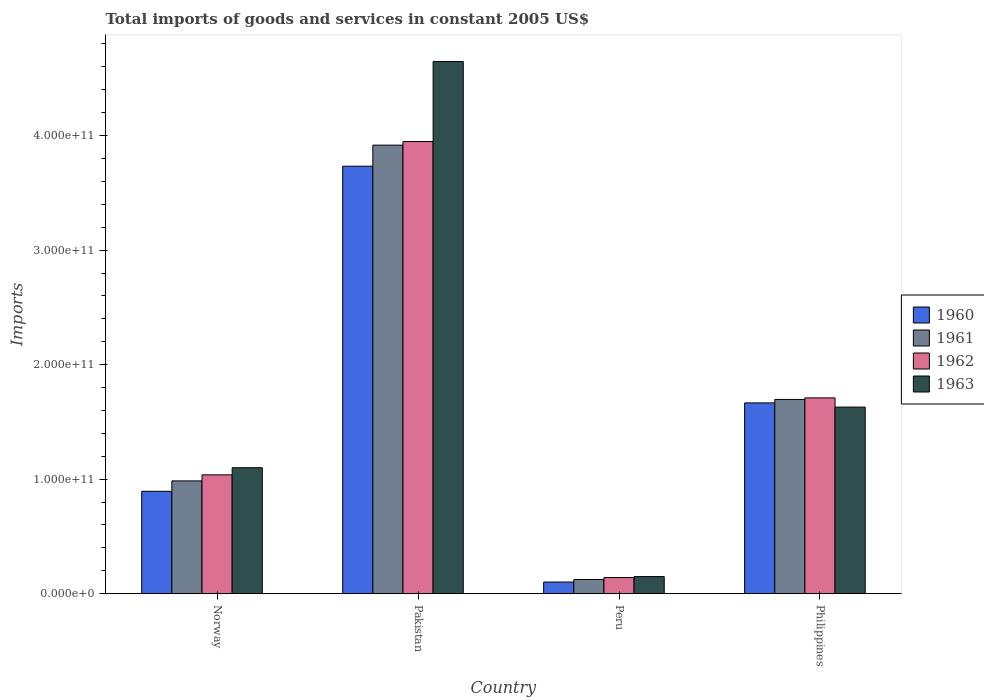How many groups of bars are there?
Offer a terse response. 4. Are the number of bars per tick equal to the number of legend labels?
Ensure brevity in your answer.  Yes. Are the number of bars on each tick of the X-axis equal?
Offer a very short reply. Yes. What is the total imports of goods and services in 1962 in Norway?
Your answer should be very brief. 1.04e+11. Across all countries, what is the maximum total imports of goods and services in 1960?
Offer a very short reply. 3.73e+11. Across all countries, what is the minimum total imports of goods and services in 1963?
Ensure brevity in your answer.  1.49e+1. In which country was the total imports of goods and services in 1963 minimum?
Your answer should be compact. Peru. What is the total total imports of goods and services in 1960 in the graph?
Ensure brevity in your answer.  6.39e+11. What is the difference between the total imports of goods and services in 1960 in Pakistan and that in Peru?
Provide a short and direct response. 3.63e+11. What is the difference between the total imports of goods and services in 1960 in Norway and the total imports of goods and services in 1961 in Peru?
Your response must be concise. 7.70e+1. What is the average total imports of goods and services in 1960 per country?
Provide a short and direct response. 1.60e+11. What is the difference between the total imports of goods and services of/in 1963 and total imports of goods and services of/in 1961 in Peru?
Give a very brief answer. 2.54e+09. In how many countries, is the total imports of goods and services in 1962 greater than 240000000000 US$?
Make the answer very short. 1. What is the ratio of the total imports of goods and services in 1963 in Peru to that in Philippines?
Make the answer very short. 0.09. Is the difference between the total imports of goods and services in 1963 in Norway and Peru greater than the difference between the total imports of goods and services in 1961 in Norway and Peru?
Keep it short and to the point. Yes. What is the difference between the highest and the second highest total imports of goods and services in 1960?
Your answer should be compact. 2.84e+11. What is the difference between the highest and the lowest total imports of goods and services in 1963?
Ensure brevity in your answer.  4.50e+11. In how many countries, is the total imports of goods and services in 1962 greater than the average total imports of goods and services in 1962 taken over all countries?
Provide a short and direct response. 2. Is the sum of the total imports of goods and services in 1960 in Peru and Philippines greater than the maximum total imports of goods and services in 1963 across all countries?
Offer a terse response. No. Is it the case that in every country, the sum of the total imports of goods and services in 1960 and total imports of goods and services in 1962 is greater than the sum of total imports of goods and services in 1963 and total imports of goods and services in 1961?
Provide a succinct answer. No. Is it the case that in every country, the sum of the total imports of goods and services in 1962 and total imports of goods and services in 1961 is greater than the total imports of goods and services in 1960?
Offer a very short reply. Yes. How many bars are there?
Keep it short and to the point. 16. What is the difference between two consecutive major ticks on the Y-axis?
Keep it short and to the point. 1.00e+11. Does the graph contain any zero values?
Your response must be concise. No. Where does the legend appear in the graph?
Offer a terse response. Center right. How many legend labels are there?
Ensure brevity in your answer.  4. What is the title of the graph?
Provide a short and direct response. Total imports of goods and services in constant 2005 US$. Does "1991" appear as one of the legend labels in the graph?
Offer a very short reply. No. What is the label or title of the Y-axis?
Provide a succinct answer. Imports. What is the Imports in 1960 in Norway?
Keep it short and to the point. 8.94e+1. What is the Imports of 1961 in Norway?
Make the answer very short. 9.85e+1. What is the Imports in 1962 in Norway?
Give a very brief answer. 1.04e+11. What is the Imports of 1963 in Norway?
Keep it short and to the point. 1.10e+11. What is the Imports in 1960 in Pakistan?
Keep it short and to the point. 3.73e+11. What is the Imports of 1961 in Pakistan?
Give a very brief answer. 3.92e+11. What is the Imports of 1962 in Pakistan?
Keep it short and to the point. 3.95e+11. What is the Imports of 1963 in Pakistan?
Your answer should be very brief. 4.65e+11. What is the Imports of 1960 in Peru?
Give a very brief answer. 1.01e+1. What is the Imports in 1961 in Peru?
Your answer should be compact. 1.24e+1. What is the Imports in 1962 in Peru?
Your answer should be very brief. 1.41e+1. What is the Imports in 1963 in Peru?
Offer a terse response. 1.49e+1. What is the Imports in 1960 in Philippines?
Your answer should be very brief. 1.67e+11. What is the Imports in 1961 in Philippines?
Keep it short and to the point. 1.70e+11. What is the Imports in 1962 in Philippines?
Your answer should be very brief. 1.71e+11. What is the Imports in 1963 in Philippines?
Your answer should be very brief. 1.63e+11. Across all countries, what is the maximum Imports of 1960?
Provide a succinct answer. 3.73e+11. Across all countries, what is the maximum Imports in 1961?
Your answer should be very brief. 3.92e+11. Across all countries, what is the maximum Imports in 1962?
Make the answer very short. 3.95e+11. Across all countries, what is the maximum Imports of 1963?
Provide a short and direct response. 4.65e+11. Across all countries, what is the minimum Imports in 1960?
Provide a succinct answer. 1.01e+1. Across all countries, what is the minimum Imports in 1961?
Provide a succinct answer. 1.24e+1. Across all countries, what is the minimum Imports in 1962?
Keep it short and to the point. 1.41e+1. Across all countries, what is the minimum Imports in 1963?
Ensure brevity in your answer.  1.49e+1. What is the total Imports in 1960 in the graph?
Ensure brevity in your answer.  6.39e+11. What is the total Imports of 1961 in the graph?
Ensure brevity in your answer.  6.72e+11. What is the total Imports in 1962 in the graph?
Provide a succinct answer. 6.84e+11. What is the total Imports of 1963 in the graph?
Give a very brief answer. 7.53e+11. What is the difference between the Imports in 1960 in Norway and that in Pakistan?
Ensure brevity in your answer.  -2.84e+11. What is the difference between the Imports in 1961 in Norway and that in Pakistan?
Make the answer very short. -2.93e+11. What is the difference between the Imports in 1962 in Norway and that in Pakistan?
Offer a terse response. -2.91e+11. What is the difference between the Imports in 1963 in Norway and that in Pakistan?
Offer a very short reply. -3.55e+11. What is the difference between the Imports in 1960 in Norway and that in Peru?
Ensure brevity in your answer.  7.92e+1. What is the difference between the Imports in 1961 in Norway and that in Peru?
Your response must be concise. 8.61e+1. What is the difference between the Imports of 1962 in Norway and that in Peru?
Provide a succinct answer. 8.97e+1. What is the difference between the Imports in 1963 in Norway and that in Peru?
Make the answer very short. 9.51e+1. What is the difference between the Imports of 1960 in Norway and that in Philippines?
Ensure brevity in your answer.  -7.72e+1. What is the difference between the Imports in 1961 in Norway and that in Philippines?
Give a very brief answer. -7.11e+1. What is the difference between the Imports in 1962 in Norway and that in Philippines?
Offer a terse response. -6.72e+1. What is the difference between the Imports in 1963 in Norway and that in Philippines?
Your answer should be very brief. -5.29e+1. What is the difference between the Imports of 1960 in Pakistan and that in Peru?
Your response must be concise. 3.63e+11. What is the difference between the Imports of 1961 in Pakistan and that in Peru?
Provide a succinct answer. 3.79e+11. What is the difference between the Imports of 1962 in Pakistan and that in Peru?
Ensure brevity in your answer.  3.81e+11. What is the difference between the Imports of 1963 in Pakistan and that in Peru?
Ensure brevity in your answer.  4.50e+11. What is the difference between the Imports in 1960 in Pakistan and that in Philippines?
Give a very brief answer. 2.07e+11. What is the difference between the Imports in 1961 in Pakistan and that in Philippines?
Provide a succinct answer. 2.22e+11. What is the difference between the Imports in 1962 in Pakistan and that in Philippines?
Your response must be concise. 2.24e+11. What is the difference between the Imports of 1963 in Pakistan and that in Philippines?
Offer a terse response. 3.02e+11. What is the difference between the Imports of 1960 in Peru and that in Philippines?
Keep it short and to the point. -1.56e+11. What is the difference between the Imports in 1961 in Peru and that in Philippines?
Offer a terse response. -1.57e+11. What is the difference between the Imports in 1962 in Peru and that in Philippines?
Your response must be concise. -1.57e+11. What is the difference between the Imports in 1963 in Peru and that in Philippines?
Your answer should be very brief. -1.48e+11. What is the difference between the Imports of 1960 in Norway and the Imports of 1961 in Pakistan?
Make the answer very short. -3.02e+11. What is the difference between the Imports in 1960 in Norway and the Imports in 1962 in Pakistan?
Give a very brief answer. -3.05e+11. What is the difference between the Imports in 1960 in Norway and the Imports in 1963 in Pakistan?
Offer a terse response. -3.75e+11. What is the difference between the Imports in 1961 in Norway and the Imports in 1962 in Pakistan?
Your answer should be very brief. -2.96e+11. What is the difference between the Imports of 1961 in Norway and the Imports of 1963 in Pakistan?
Your response must be concise. -3.66e+11. What is the difference between the Imports of 1962 in Norway and the Imports of 1963 in Pakistan?
Provide a short and direct response. -3.61e+11. What is the difference between the Imports of 1960 in Norway and the Imports of 1961 in Peru?
Offer a very short reply. 7.70e+1. What is the difference between the Imports of 1960 in Norway and the Imports of 1962 in Peru?
Your answer should be very brief. 7.53e+1. What is the difference between the Imports of 1960 in Norway and the Imports of 1963 in Peru?
Give a very brief answer. 7.45e+1. What is the difference between the Imports of 1961 in Norway and the Imports of 1962 in Peru?
Keep it short and to the point. 8.44e+1. What is the difference between the Imports in 1961 in Norway and the Imports in 1963 in Peru?
Your answer should be very brief. 8.35e+1. What is the difference between the Imports of 1962 in Norway and the Imports of 1963 in Peru?
Give a very brief answer. 8.88e+1. What is the difference between the Imports in 1960 in Norway and the Imports in 1961 in Philippines?
Your answer should be compact. -8.02e+1. What is the difference between the Imports of 1960 in Norway and the Imports of 1962 in Philippines?
Offer a terse response. -8.16e+1. What is the difference between the Imports of 1960 in Norway and the Imports of 1963 in Philippines?
Your answer should be compact. -7.35e+1. What is the difference between the Imports of 1961 in Norway and the Imports of 1962 in Philippines?
Ensure brevity in your answer.  -7.25e+1. What is the difference between the Imports of 1961 in Norway and the Imports of 1963 in Philippines?
Give a very brief answer. -6.44e+1. What is the difference between the Imports of 1962 in Norway and the Imports of 1963 in Philippines?
Your answer should be compact. -5.92e+1. What is the difference between the Imports of 1960 in Pakistan and the Imports of 1961 in Peru?
Provide a short and direct response. 3.61e+11. What is the difference between the Imports in 1960 in Pakistan and the Imports in 1962 in Peru?
Ensure brevity in your answer.  3.59e+11. What is the difference between the Imports of 1960 in Pakistan and the Imports of 1963 in Peru?
Provide a succinct answer. 3.58e+11. What is the difference between the Imports of 1961 in Pakistan and the Imports of 1962 in Peru?
Your answer should be very brief. 3.78e+11. What is the difference between the Imports of 1961 in Pakistan and the Imports of 1963 in Peru?
Your answer should be very brief. 3.77e+11. What is the difference between the Imports of 1962 in Pakistan and the Imports of 1963 in Peru?
Ensure brevity in your answer.  3.80e+11. What is the difference between the Imports of 1960 in Pakistan and the Imports of 1961 in Philippines?
Your answer should be compact. 2.04e+11. What is the difference between the Imports in 1960 in Pakistan and the Imports in 1962 in Philippines?
Give a very brief answer. 2.02e+11. What is the difference between the Imports of 1960 in Pakistan and the Imports of 1963 in Philippines?
Ensure brevity in your answer.  2.10e+11. What is the difference between the Imports in 1961 in Pakistan and the Imports in 1962 in Philippines?
Offer a very short reply. 2.21e+11. What is the difference between the Imports in 1961 in Pakistan and the Imports in 1963 in Philippines?
Provide a succinct answer. 2.29e+11. What is the difference between the Imports of 1962 in Pakistan and the Imports of 1963 in Philippines?
Your answer should be very brief. 2.32e+11. What is the difference between the Imports of 1960 in Peru and the Imports of 1961 in Philippines?
Your response must be concise. -1.59e+11. What is the difference between the Imports of 1960 in Peru and the Imports of 1962 in Philippines?
Provide a short and direct response. -1.61e+11. What is the difference between the Imports in 1960 in Peru and the Imports in 1963 in Philippines?
Ensure brevity in your answer.  -1.53e+11. What is the difference between the Imports of 1961 in Peru and the Imports of 1962 in Philippines?
Offer a very short reply. -1.59e+11. What is the difference between the Imports in 1961 in Peru and the Imports in 1963 in Philippines?
Your answer should be compact. -1.51e+11. What is the difference between the Imports of 1962 in Peru and the Imports of 1963 in Philippines?
Your answer should be compact. -1.49e+11. What is the average Imports of 1960 per country?
Your response must be concise. 1.60e+11. What is the average Imports in 1961 per country?
Provide a succinct answer. 1.68e+11. What is the average Imports in 1962 per country?
Give a very brief answer. 1.71e+11. What is the average Imports in 1963 per country?
Offer a very short reply. 1.88e+11. What is the difference between the Imports of 1960 and Imports of 1961 in Norway?
Give a very brief answer. -9.07e+09. What is the difference between the Imports of 1960 and Imports of 1962 in Norway?
Your answer should be compact. -1.44e+1. What is the difference between the Imports in 1960 and Imports in 1963 in Norway?
Your answer should be compact. -2.06e+1. What is the difference between the Imports of 1961 and Imports of 1962 in Norway?
Ensure brevity in your answer.  -5.28e+09. What is the difference between the Imports in 1961 and Imports in 1963 in Norway?
Your response must be concise. -1.15e+1. What is the difference between the Imports in 1962 and Imports in 1963 in Norway?
Offer a very short reply. -6.24e+09. What is the difference between the Imports of 1960 and Imports of 1961 in Pakistan?
Your response must be concise. -1.84e+1. What is the difference between the Imports in 1960 and Imports in 1962 in Pakistan?
Offer a terse response. -2.15e+1. What is the difference between the Imports in 1960 and Imports in 1963 in Pakistan?
Offer a terse response. -9.14e+1. What is the difference between the Imports in 1961 and Imports in 1962 in Pakistan?
Provide a short and direct response. -3.12e+09. What is the difference between the Imports in 1961 and Imports in 1963 in Pakistan?
Give a very brief answer. -7.30e+1. What is the difference between the Imports of 1962 and Imports of 1963 in Pakistan?
Ensure brevity in your answer.  -6.99e+1. What is the difference between the Imports of 1960 and Imports of 1961 in Peru?
Your response must be concise. -2.24e+09. What is the difference between the Imports in 1960 and Imports in 1962 in Peru?
Your answer should be compact. -3.92e+09. What is the difference between the Imports of 1960 and Imports of 1963 in Peru?
Make the answer very short. -4.78e+09. What is the difference between the Imports of 1961 and Imports of 1962 in Peru?
Provide a succinct answer. -1.68e+09. What is the difference between the Imports of 1961 and Imports of 1963 in Peru?
Make the answer very short. -2.54e+09. What is the difference between the Imports of 1962 and Imports of 1963 in Peru?
Your response must be concise. -8.62e+08. What is the difference between the Imports in 1960 and Imports in 1961 in Philippines?
Offer a very short reply. -3.01e+09. What is the difference between the Imports in 1960 and Imports in 1962 in Philippines?
Make the answer very short. -4.37e+09. What is the difference between the Imports in 1960 and Imports in 1963 in Philippines?
Keep it short and to the point. 3.68e+09. What is the difference between the Imports of 1961 and Imports of 1962 in Philippines?
Offer a very short reply. -1.36e+09. What is the difference between the Imports in 1961 and Imports in 1963 in Philippines?
Your response must be concise. 6.69e+09. What is the difference between the Imports of 1962 and Imports of 1963 in Philippines?
Your answer should be very brief. 8.04e+09. What is the ratio of the Imports in 1960 in Norway to that in Pakistan?
Offer a terse response. 0.24. What is the ratio of the Imports in 1961 in Norway to that in Pakistan?
Your answer should be very brief. 0.25. What is the ratio of the Imports in 1962 in Norway to that in Pakistan?
Offer a terse response. 0.26. What is the ratio of the Imports in 1963 in Norway to that in Pakistan?
Give a very brief answer. 0.24. What is the ratio of the Imports in 1960 in Norway to that in Peru?
Keep it short and to the point. 8.81. What is the ratio of the Imports in 1961 in Norway to that in Peru?
Offer a very short reply. 7.95. What is the ratio of the Imports of 1962 in Norway to that in Peru?
Provide a short and direct response. 7.38. What is the ratio of the Imports of 1963 in Norway to that in Peru?
Give a very brief answer. 7.37. What is the ratio of the Imports of 1960 in Norway to that in Philippines?
Your response must be concise. 0.54. What is the ratio of the Imports of 1961 in Norway to that in Philippines?
Keep it short and to the point. 0.58. What is the ratio of the Imports in 1962 in Norway to that in Philippines?
Make the answer very short. 0.61. What is the ratio of the Imports in 1963 in Norway to that in Philippines?
Make the answer very short. 0.68. What is the ratio of the Imports of 1960 in Pakistan to that in Peru?
Your answer should be compact. 36.79. What is the ratio of the Imports of 1961 in Pakistan to that in Peru?
Provide a short and direct response. 31.62. What is the ratio of the Imports in 1962 in Pakistan to that in Peru?
Give a very brief answer. 28.07. What is the ratio of the Imports of 1963 in Pakistan to that in Peru?
Provide a succinct answer. 31.13. What is the ratio of the Imports in 1960 in Pakistan to that in Philippines?
Ensure brevity in your answer.  2.24. What is the ratio of the Imports of 1961 in Pakistan to that in Philippines?
Your answer should be compact. 2.31. What is the ratio of the Imports in 1962 in Pakistan to that in Philippines?
Make the answer very short. 2.31. What is the ratio of the Imports in 1963 in Pakistan to that in Philippines?
Provide a succinct answer. 2.85. What is the ratio of the Imports of 1960 in Peru to that in Philippines?
Give a very brief answer. 0.06. What is the ratio of the Imports in 1961 in Peru to that in Philippines?
Offer a very short reply. 0.07. What is the ratio of the Imports in 1962 in Peru to that in Philippines?
Your answer should be compact. 0.08. What is the ratio of the Imports in 1963 in Peru to that in Philippines?
Your answer should be very brief. 0.09. What is the difference between the highest and the second highest Imports in 1960?
Keep it short and to the point. 2.07e+11. What is the difference between the highest and the second highest Imports of 1961?
Your answer should be compact. 2.22e+11. What is the difference between the highest and the second highest Imports in 1962?
Provide a short and direct response. 2.24e+11. What is the difference between the highest and the second highest Imports in 1963?
Your answer should be compact. 3.02e+11. What is the difference between the highest and the lowest Imports in 1960?
Your answer should be compact. 3.63e+11. What is the difference between the highest and the lowest Imports in 1961?
Provide a short and direct response. 3.79e+11. What is the difference between the highest and the lowest Imports of 1962?
Your answer should be very brief. 3.81e+11. What is the difference between the highest and the lowest Imports of 1963?
Give a very brief answer. 4.50e+11. 